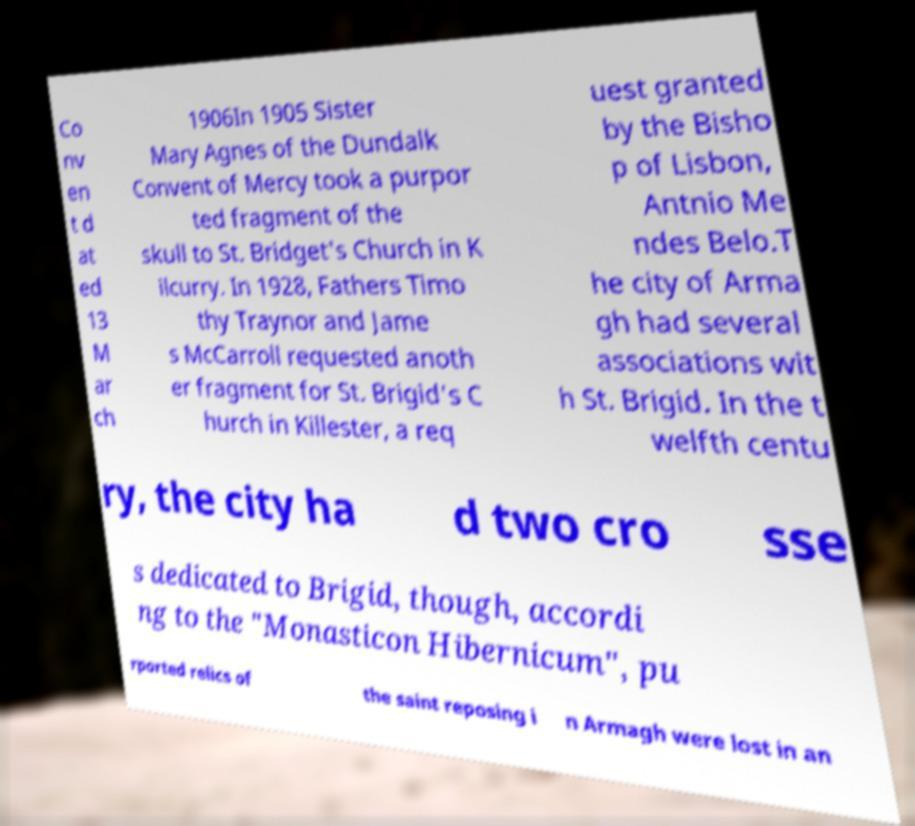Please read and relay the text visible in this image. What does it say? Co nv en t d at ed 13 M ar ch 1906In 1905 Sister Mary Agnes of the Dundalk Convent of Mercy took a purpor ted fragment of the skull to St. Bridget's Church in K ilcurry. In 1928, Fathers Timo thy Traynor and Jame s McCarroll requested anoth er fragment for St. Brigid's C hurch in Killester, a req uest granted by the Bisho p of Lisbon, Antnio Me ndes Belo.T he city of Arma gh had several associations wit h St. Brigid. In the t welfth centu ry, the city ha d two cro sse s dedicated to Brigid, though, accordi ng to the "Monasticon Hibernicum", pu rported relics of the saint reposing i n Armagh were lost in an 